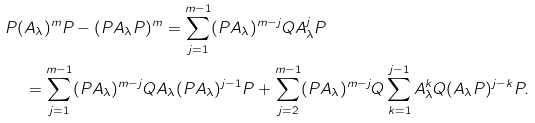Convert formula to latex. <formula><loc_0><loc_0><loc_500><loc_500>P ( & A _ { \lambda } ) ^ { m } P - ( P A _ { \lambda } P ) ^ { m } = \sum _ { j = 1 } ^ { m - 1 } ( P A _ { \lambda } ) ^ { m - j } Q A _ { \lambda } ^ { j } P \\ & = \sum _ { j = 1 } ^ { m - 1 } ( P A _ { \lambda } ) ^ { m - j } Q A _ { \lambda } ( P A _ { \lambda } ) ^ { j - 1 } P + \sum _ { j = 2 } ^ { m - 1 } ( P A _ { \lambda } ) ^ { m - j } Q \sum _ { k = 1 } ^ { j - 1 } A _ { \lambda } ^ { k } Q ( A _ { \lambda } P ) ^ { j - k } P .</formula> 